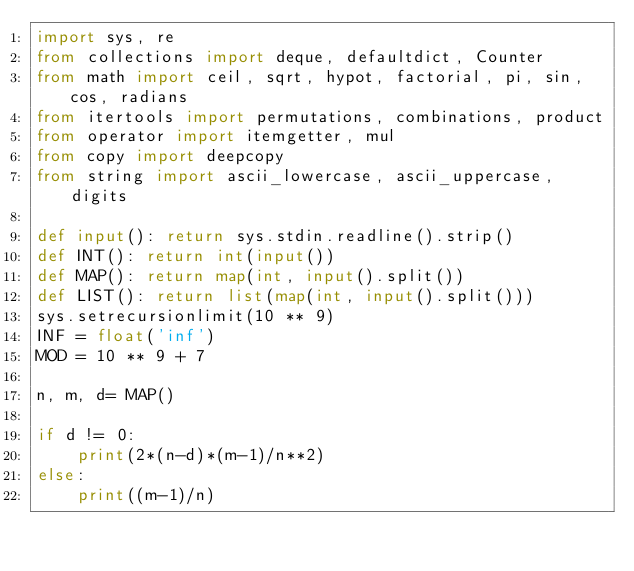Convert code to text. <code><loc_0><loc_0><loc_500><loc_500><_Python_>import sys, re
from collections import deque, defaultdict, Counter
from math import ceil, sqrt, hypot, factorial, pi, sin, cos, radians
from itertools import permutations, combinations, product
from operator import itemgetter, mul
from copy import deepcopy
from string import ascii_lowercase, ascii_uppercase, digits

def input(): return sys.stdin.readline().strip()
def INT(): return int(input())
def MAP(): return map(int, input().split())
def LIST(): return list(map(int, input().split()))
sys.setrecursionlimit(10 ** 9)
INF = float('inf')
MOD = 10 ** 9 + 7

n, m, d= MAP()

if d != 0:
	print(2*(n-d)*(m-1)/n**2)
else:
	print((m-1)/n)</code> 